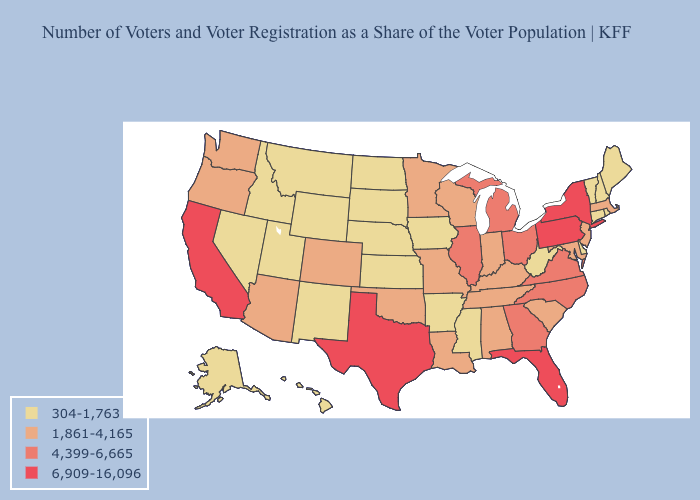What is the highest value in the Northeast ?
Be succinct. 6,909-16,096. What is the highest value in states that border New York?
Be succinct. 6,909-16,096. Does West Virginia have the highest value in the USA?
Write a very short answer. No. What is the value of Nevada?
Be succinct. 304-1,763. What is the highest value in the USA?
Concise answer only. 6,909-16,096. Name the states that have a value in the range 4,399-6,665?
Answer briefly. Georgia, Illinois, Michigan, North Carolina, Ohio, Virginia. What is the highest value in the USA?
Answer briefly. 6,909-16,096. Name the states that have a value in the range 6,909-16,096?
Answer briefly. California, Florida, New York, Pennsylvania, Texas. Does the first symbol in the legend represent the smallest category?
Be succinct. Yes. Among the states that border Arkansas , does Texas have the highest value?
Short answer required. Yes. What is the value of Nevada?
Be succinct. 304-1,763. How many symbols are there in the legend?
Give a very brief answer. 4. Which states have the lowest value in the Northeast?
Short answer required. Connecticut, Maine, New Hampshire, Rhode Island, Vermont. Which states hav the highest value in the West?
Answer briefly. California. What is the value of North Dakota?
Answer briefly. 304-1,763. 